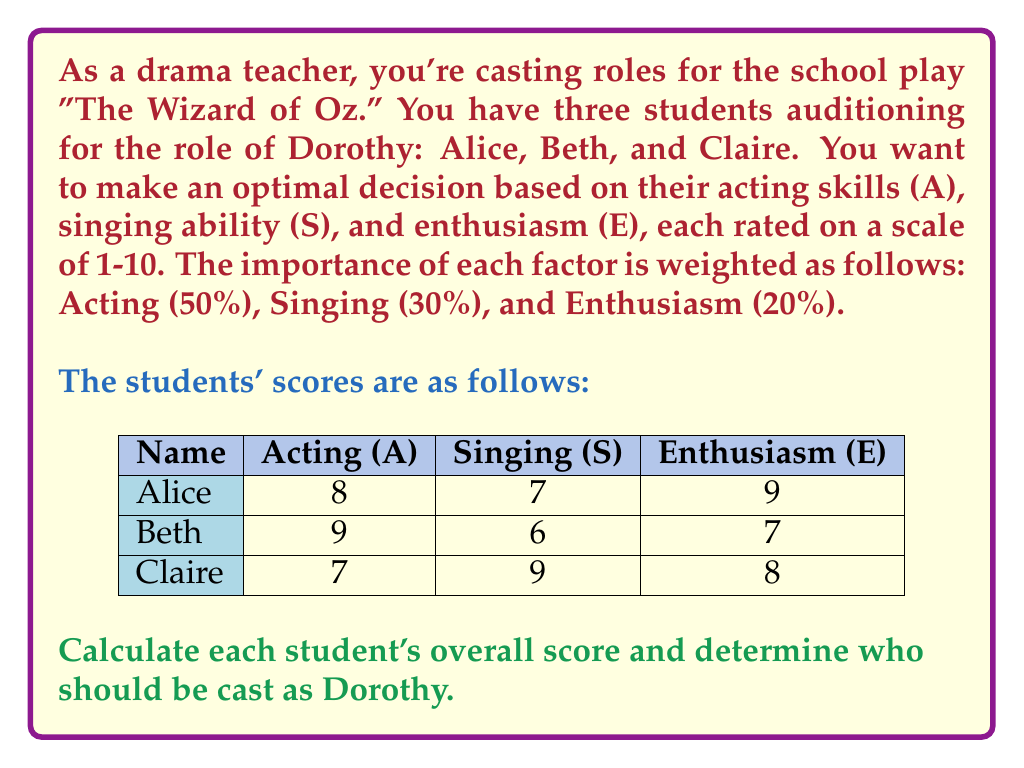Can you solve this math problem? To solve this problem, we'll follow these steps:

1) First, let's define our decision function. For each student, we'll calculate a weighted score:

   $$ \text{Score} = 0.5A + 0.3S + 0.2E $$

   Where A is Acting, S is Singing, and E is Enthusiasm.

2) Now, let's calculate the score for each student:

   For Alice:
   $$ \text{Score}_\text{Alice} = 0.5(8) + 0.3(7) + 0.2(9) = 4 + 2.1 + 1.8 = 7.9 $$

   For Beth:
   $$ \text{Score}_\text{Beth} = 0.5(9) + 0.3(6) + 0.2(7) = 4.5 + 1.8 + 1.4 = 7.7 $$

   For Claire:
   $$ \text{Score}_\text{Claire} = 0.5(7) + 0.3(9) + 0.2(8) = 3.5 + 2.7 + 1.6 = 7.8 $$

3) Now we compare the scores:

   Alice: 7.9
   Beth: 7.7
   Claire: 7.8

4) The highest score determines the optimal choice for the role of Dorothy.
Answer: Alice should be cast as Dorothy (Score: 7.9). 